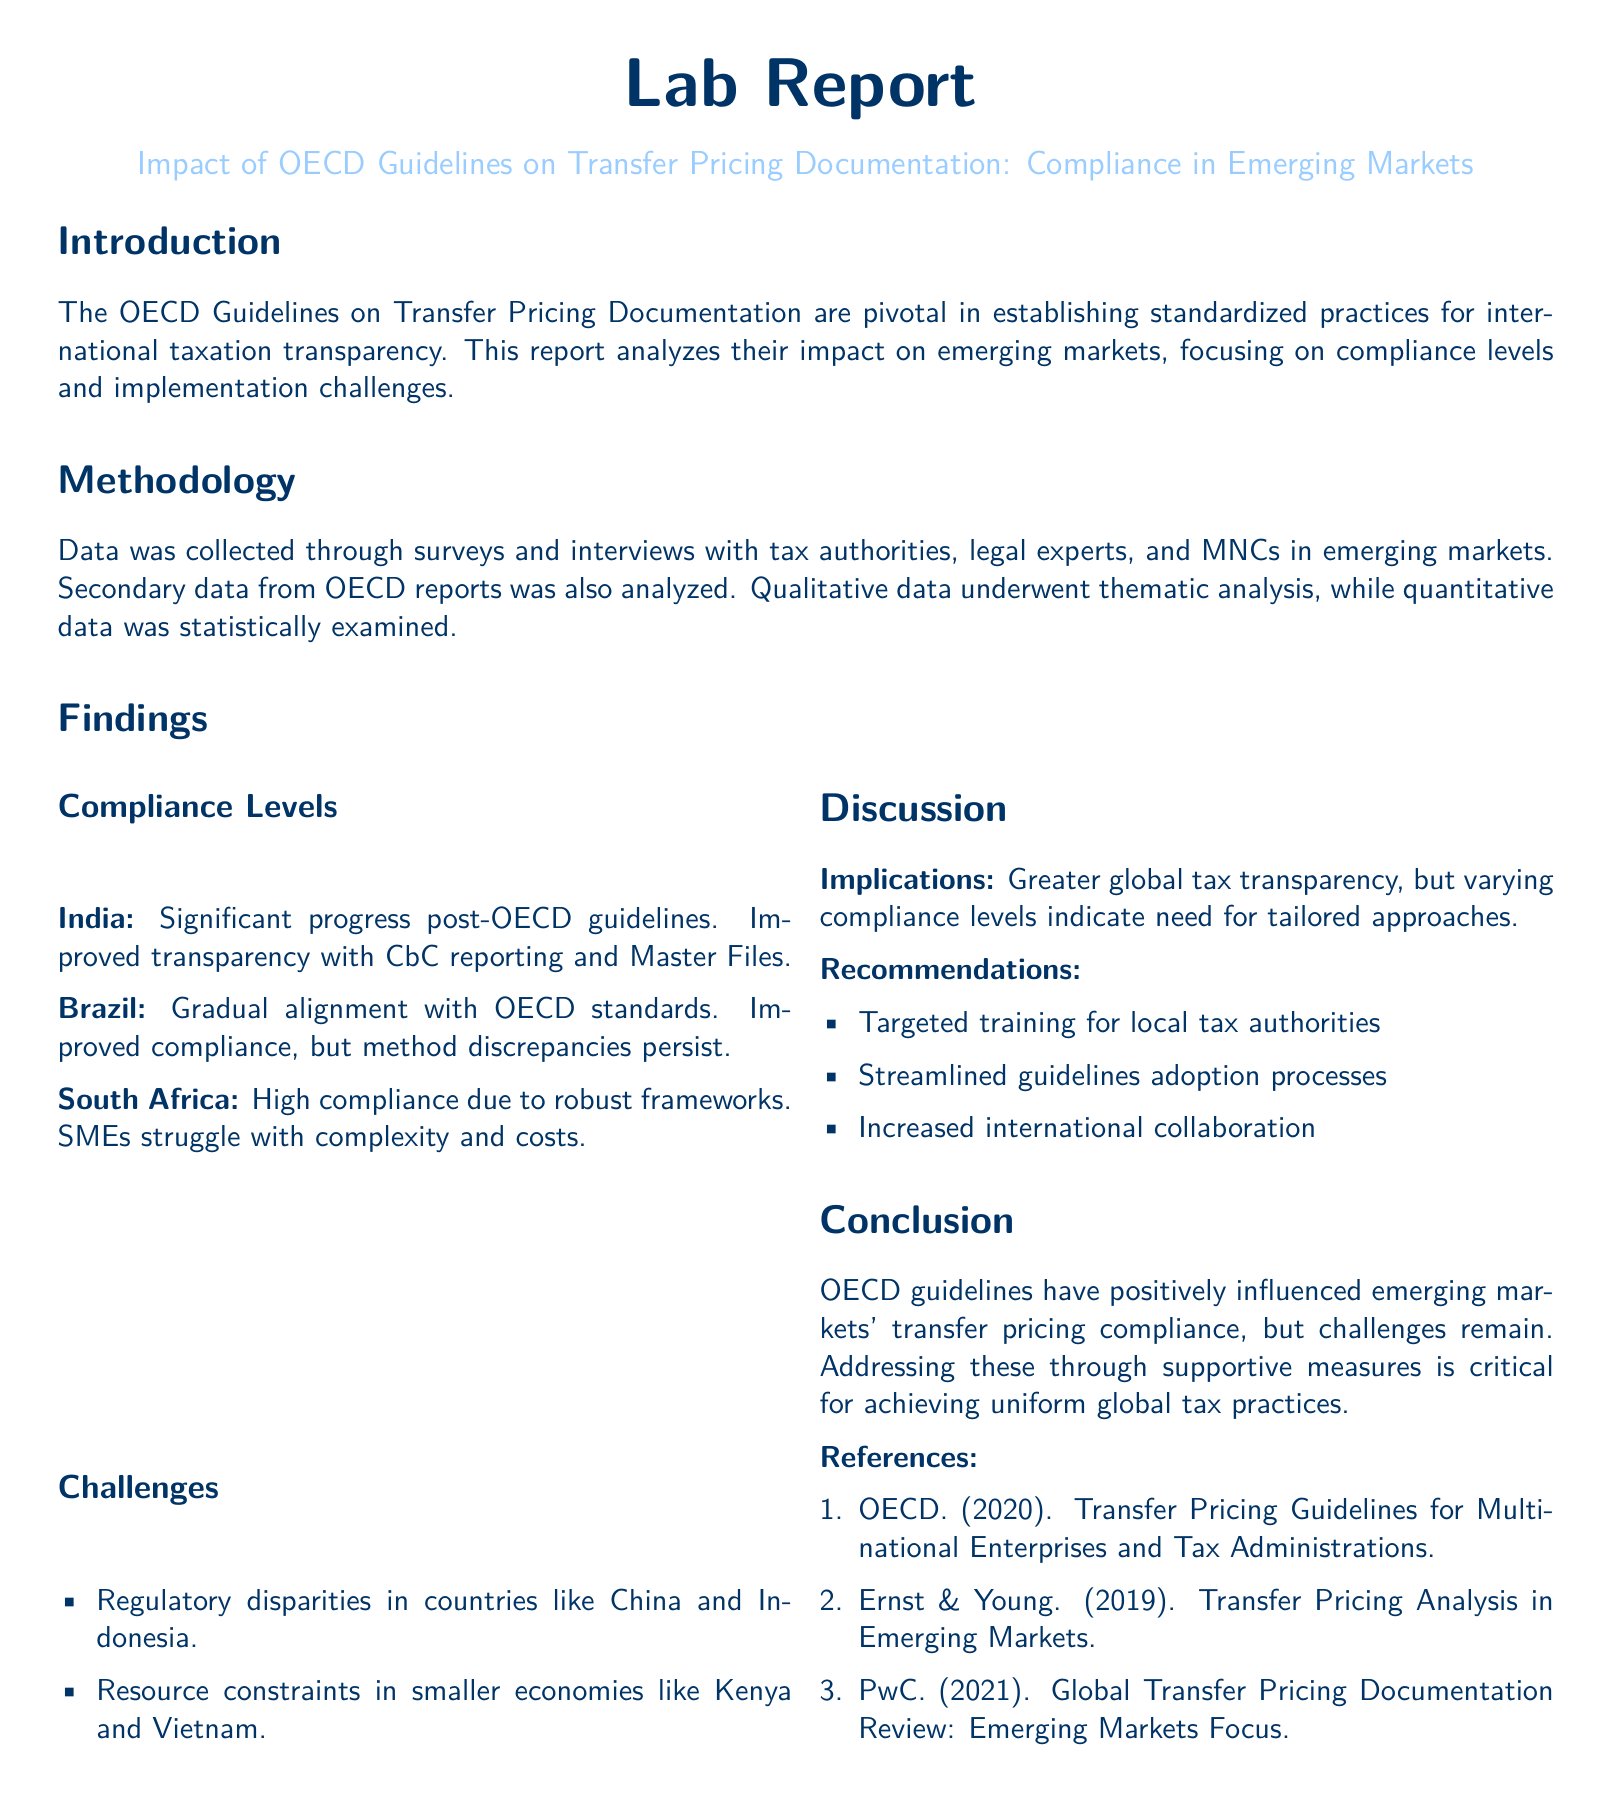What is the main focus of the report? The report analyzes the impact of OECD guidelines on transfer pricing documentation and compliance in emerging markets.
Answer: OECD guidelines on transfer pricing documentation Which country showed significant progress post-OECD guidelines? The report mentions India as having made significant progress post-OECD guidelines.
Answer: India What challenges do SMEs face in South Africa? The report states that SMEs in South Africa struggle with complexity and costs.
Answer: Complexity and costs What is a key recommendation provided in the report? A recommendation made in the report is to provide targeted training for local tax authorities.
Answer: Targeted training for local tax authorities Which methodology was used to analyze qualitative data? The thematic analysis was used for analyzing qualitative data in the report.
Answer: Thematic analysis What type of data analysis was performed on quantitative data? The report indicates that quantitative data underwent statistical examination.
Answer: Statistical examination Which country is noted for its high compliance due to robust frameworks? South Africa is noted for its high compliance due to robust frameworks.
Answer: South Africa What are regulatory disparities mentioned in the report? The document mentions regulatory disparities in countries like China and Indonesia.
Answer: China and Indonesia What was the publication year of the OECD guidelines referenced? The OECD guidelines referenced in the report were published in 2020.
Answer: 2020 